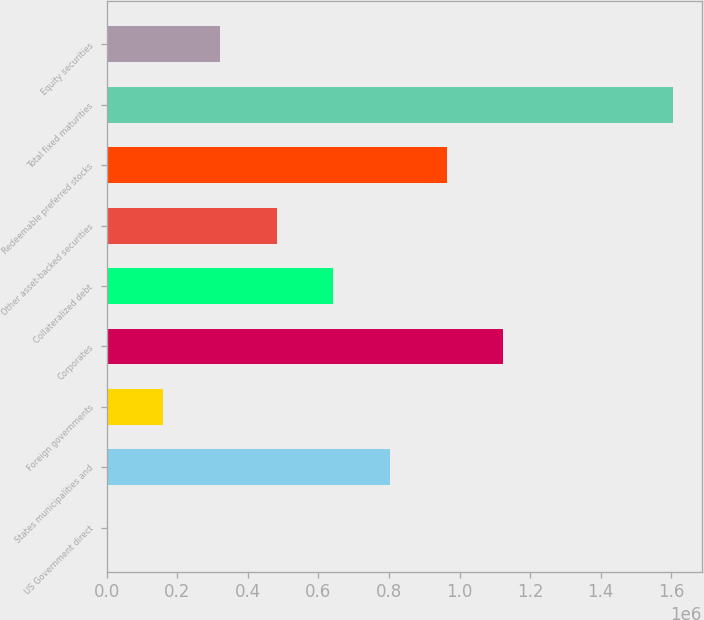<chart> <loc_0><loc_0><loc_500><loc_500><bar_chart><fcel>US Government direct<fcel>States municipalities and<fcel>Foreign governments<fcel>Corporates<fcel>Collateralized debt<fcel>Other asset-backed securities<fcel>Redeemable preferred stocks<fcel>Total fixed maturities<fcel>Equity securities<nl><fcel>4.67<fcel>803121<fcel>160628<fcel>1.12437e+06<fcel>642498<fcel>481875<fcel>963745<fcel>1.60624e+06<fcel>321251<nl></chart> 